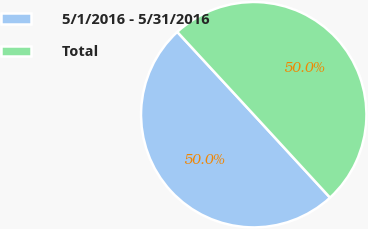Convert chart to OTSL. <chart><loc_0><loc_0><loc_500><loc_500><pie_chart><fcel>5/1/2016 - 5/31/2016<fcel>Total<nl><fcel>49.97%<fcel>50.03%<nl></chart> 